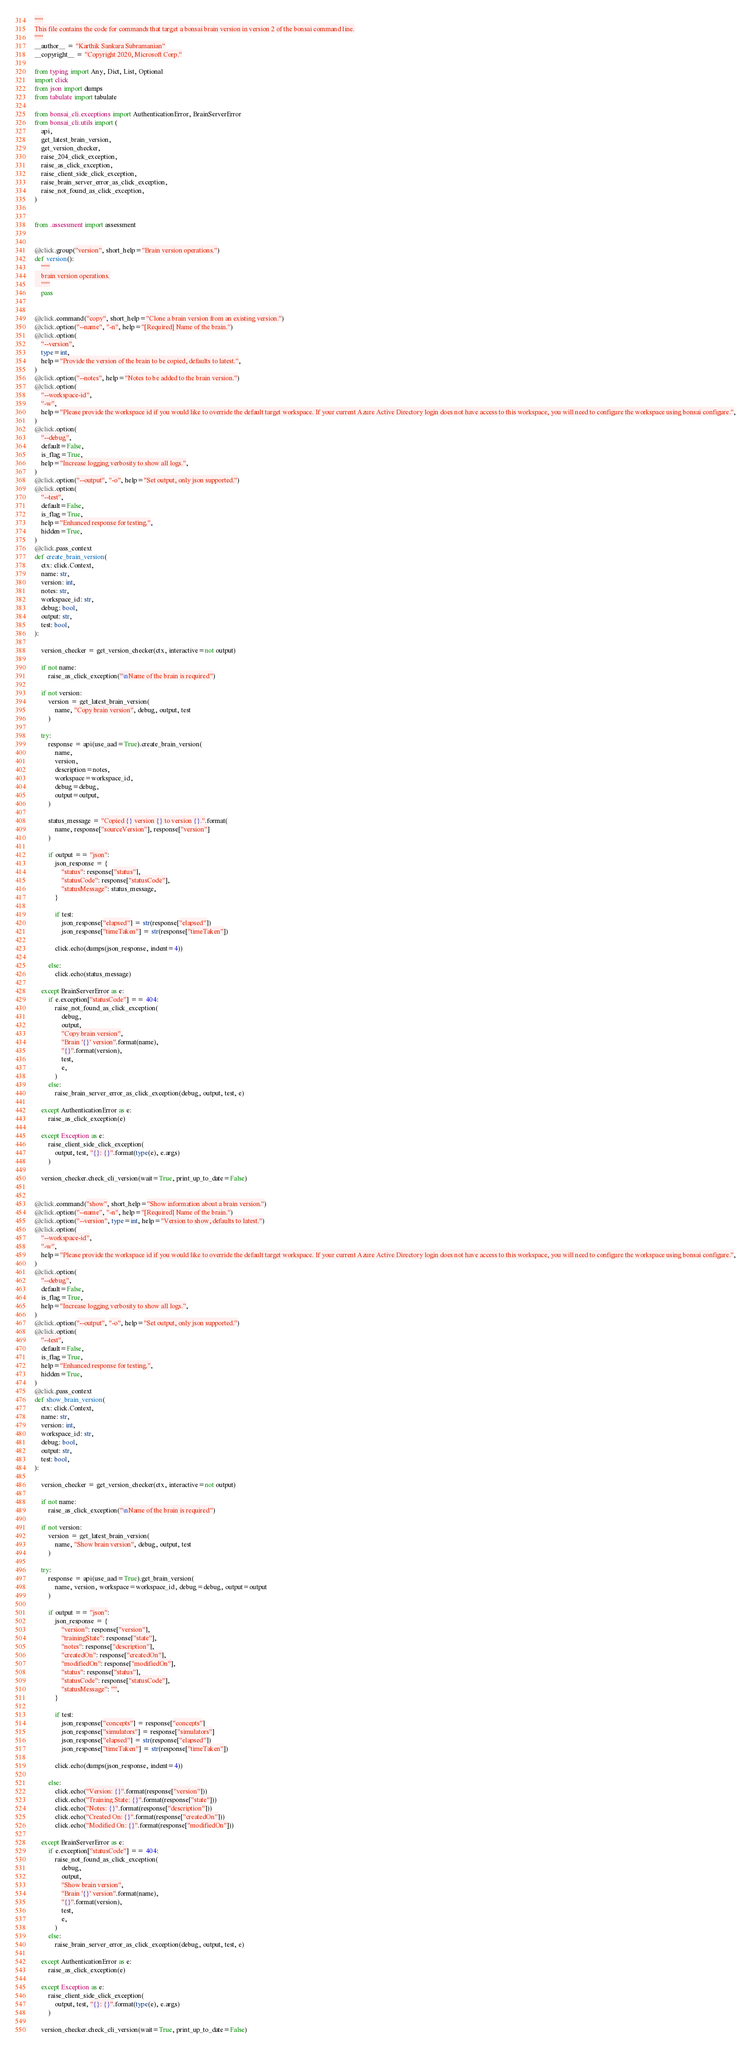Convert code to text. <code><loc_0><loc_0><loc_500><loc_500><_Python_>"""
This file contains the code for commands that target a bonsai brain version in version 2 of the bonsai command line.
"""
__author__ = "Karthik Sankara Subramanian"
__copyright__ = "Copyright 2020, Microsoft Corp."

from typing import Any, Dict, List, Optional
import click
from json import dumps
from tabulate import tabulate

from bonsai_cli.exceptions import AuthenticationError, BrainServerError
from bonsai_cli.utils import (
    api,
    get_latest_brain_version,
    get_version_checker,
    raise_204_click_exception,
    raise_as_click_exception,
    raise_client_side_click_exception,
    raise_brain_server_error_as_click_exception,
    raise_not_found_as_click_exception,
)


from .assessment import assessment


@click.group("version", short_help="Brain version operations.")
def version():
    """
    brain version operations.
    """
    pass


@click.command("copy", short_help="Clone a brain version from an existing version.")
@click.option("--name", "-n", help="[Required] Name of the brain.")
@click.option(
    "--version",
    type=int,
    help="Provide the version of the brain to be copied, defaults to latest.",
)
@click.option("--notes", help="Notes to be added to the brain version.")
@click.option(
    "--workspace-id",
    "-w",
    help="Please provide the workspace id if you would like to override the default target workspace. If your current Azure Active Directory login does not have access to this workspace, you will need to configure the workspace using bonsai configure.",
)
@click.option(
    "--debug",
    default=False,
    is_flag=True,
    help="Increase logging verbosity to show all logs.",
)
@click.option("--output", "-o", help="Set output, only json supported.")
@click.option(
    "--test",
    default=False,
    is_flag=True,
    help="Enhanced response for testing.",
    hidden=True,
)
@click.pass_context
def create_brain_version(
    ctx: click.Context,
    name: str,
    version: int,
    notes: str,
    workspace_id: str,
    debug: bool,
    output: str,
    test: bool,
):

    version_checker = get_version_checker(ctx, interactive=not output)

    if not name:
        raise_as_click_exception("\nName of the brain is required")

    if not version:
        version = get_latest_brain_version(
            name, "Copy brain version", debug, output, test
        )

    try:
        response = api(use_aad=True).create_brain_version(
            name,
            version,
            description=notes,
            workspace=workspace_id,
            debug=debug,
            output=output,
        )

        status_message = "Copied {} version {} to version {}.".format(
            name, response["sourceVersion"], response["version"]
        )

        if output == "json":
            json_response = {
                "status": response["status"],
                "statusCode": response["statusCode"],
                "statusMessage": status_message,
            }

            if test:
                json_response["elapsed"] = str(response["elapsed"])
                json_response["timeTaken"] = str(response["timeTaken"])

            click.echo(dumps(json_response, indent=4))

        else:
            click.echo(status_message)

    except BrainServerError as e:
        if e.exception["statusCode"] == 404:
            raise_not_found_as_click_exception(
                debug,
                output,
                "Copy brain version",
                "Brain '{}' version".format(name),
                "{}".format(version),
                test,
                e,
            )
        else:
            raise_brain_server_error_as_click_exception(debug, output, test, e)

    except AuthenticationError as e:
        raise_as_click_exception(e)

    except Exception as e:
        raise_client_side_click_exception(
            output, test, "{}: {}".format(type(e), e.args)
        )

    version_checker.check_cli_version(wait=True, print_up_to_date=False)


@click.command("show", short_help="Show information about a brain version.")
@click.option("--name", "-n", help="[Required] Name of the brain.")
@click.option("--version", type=int, help="Version to show, defaults to latest.")
@click.option(
    "--workspace-id",
    "-w",
    help="Please provide the workspace id if you would like to override the default target workspace. If your current Azure Active Directory login does not have access to this workspace, you will need to configure the workspace using bonsai configure.",
)
@click.option(
    "--debug",
    default=False,
    is_flag=True,
    help="Increase logging verbosity to show all logs.",
)
@click.option("--output", "-o", help="Set output, only json supported.")
@click.option(
    "--test",
    default=False,
    is_flag=True,
    help="Enhanced response for testing.",
    hidden=True,
)
@click.pass_context
def show_brain_version(
    ctx: click.Context,
    name: str,
    version: int,
    workspace_id: str,
    debug: bool,
    output: str,
    test: bool,
):

    version_checker = get_version_checker(ctx, interactive=not output)

    if not name:
        raise_as_click_exception("\nName of the brain is required")

    if not version:
        version = get_latest_brain_version(
            name, "Show brain version", debug, output, test
        )

    try:
        response = api(use_aad=True).get_brain_version(
            name, version, workspace=workspace_id, debug=debug, output=output
        )

        if output == "json":
            json_response = {
                "version": response["version"],
                "trainingState": response["state"],
                "notes": response["description"],
                "createdOn": response["createdOn"],
                "modifiedOn": response["modifiedOn"],
                "status": response["status"],
                "statusCode": response["statusCode"],
                "statusMessage": "",
            }

            if test:
                json_response["concepts"] = response["concepts"]
                json_response["simulators"] = response["simulators"]
                json_response["elapsed"] = str(response["elapsed"])
                json_response["timeTaken"] = str(response["timeTaken"])

            click.echo(dumps(json_response, indent=4))

        else:
            click.echo("Version: {}".format(response["version"]))
            click.echo("Training State: {}".format(response["state"]))
            click.echo("Notes: {}".format(response["description"]))
            click.echo("Created On: {}".format(response["createdOn"]))
            click.echo("Modified On: {}".format(response["modifiedOn"]))

    except BrainServerError as e:
        if e.exception["statusCode"] == 404:
            raise_not_found_as_click_exception(
                debug,
                output,
                "Show brain version",
                "Brain '{}' version".format(name),
                "{}".format(version),
                test,
                e,
            )
        else:
            raise_brain_server_error_as_click_exception(debug, output, test, e)

    except AuthenticationError as e:
        raise_as_click_exception(e)

    except Exception as e:
        raise_client_side_click_exception(
            output, test, "{}: {}".format(type(e), e.args)
        )

    version_checker.check_cli_version(wait=True, print_up_to_date=False)

</code> 